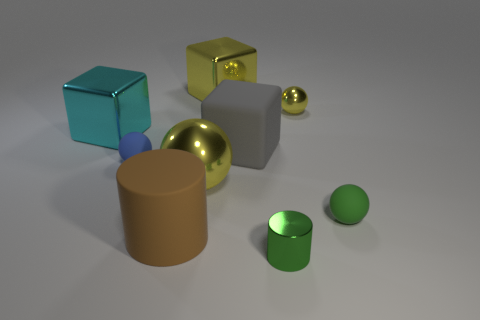Is the large metal ball the same color as the small shiny sphere?
Provide a succinct answer. Yes. What is the shape of the tiny shiny thing behind the big yellow object in front of the large metallic object behind the small yellow thing?
Give a very brief answer. Sphere. The blue object is what size?
Your response must be concise. Small. The large cylinder that is made of the same material as the green ball is what color?
Offer a terse response. Brown. How many big yellow objects are made of the same material as the large yellow cube?
Keep it short and to the point. 1. There is a big cylinder; does it have the same color as the tiny matte sphere behind the big yellow metallic sphere?
Give a very brief answer. No. What color is the tiny sphere on the left side of the big matte thing that is in front of the big yellow metal sphere?
Your response must be concise. Blue. There is a ball that is the same size as the yellow shiny block; what color is it?
Make the answer very short. Yellow. Is there a blue rubber thing of the same shape as the gray matte thing?
Make the answer very short. No. There is a big cyan metal object; what shape is it?
Keep it short and to the point. Cube. 